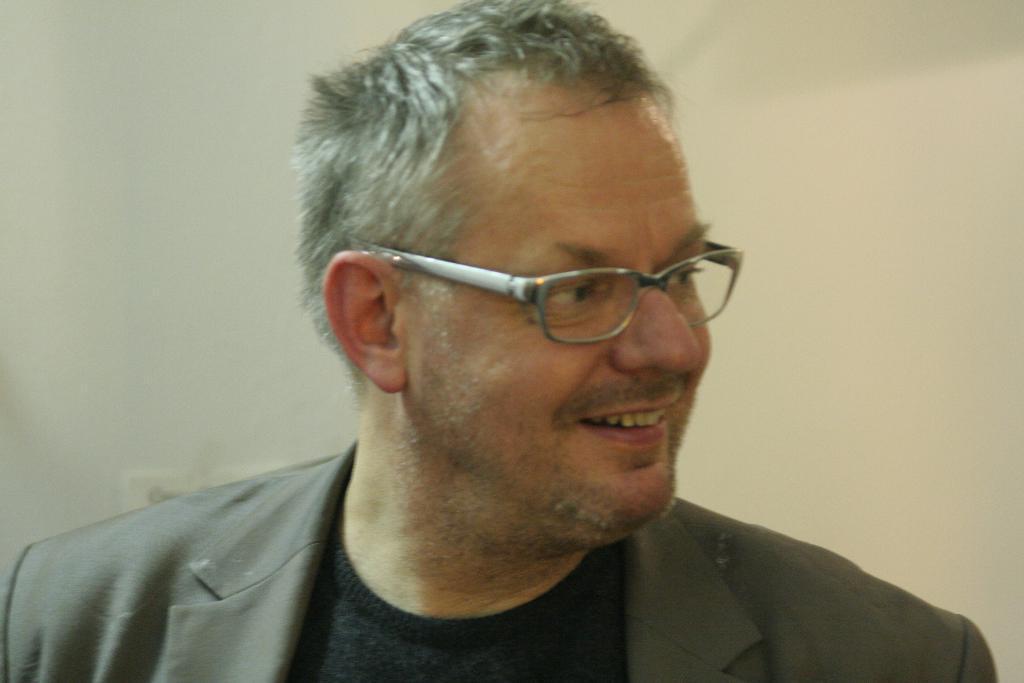How would you summarize this image in a sentence or two? In the foreground of this image, there is a, man in the suit and in the background, there is a white wall. 